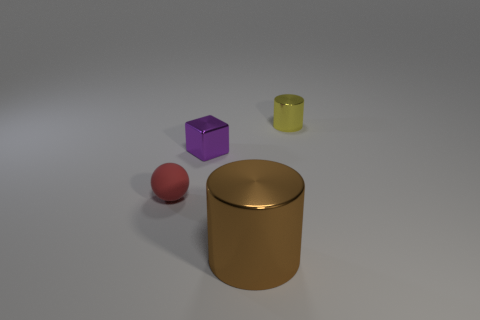Add 1 small brown objects. How many objects exist? 5 Subtract all blocks. How many objects are left? 3 Subtract all big cyan matte blocks. Subtract all red rubber objects. How many objects are left? 3 Add 3 tiny balls. How many tiny balls are left? 4 Add 1 small gray matte blocks. How many small gray matte blocks exist? 1 Subtract 0 blue cubes. How many objects are left? 4 